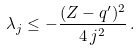Convert formula to latex. <formula><loc_0><loc_0><loc_500><loc_500>\lambda _ { j } \leq - \frac { ( Z - q ^ { \prime } ) ^ { 2 } } { 4 \, j ^ { 2 } } \, .</formula> 